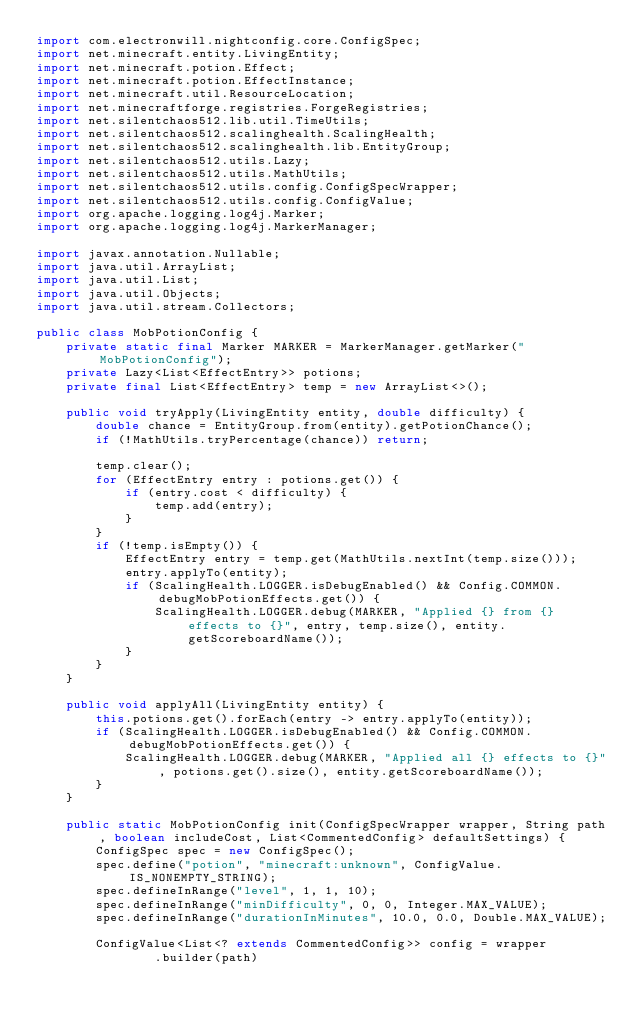Convert code to text. <code><loc_0><loc_0><loc_500><loc_500><_Java_>import com.electronwill.nightconfig.core.ConfigSpec;
import net.minecraft.entity.LivingEntity;
import net.minecraft.potion.Effect;
import net.minecraft.potion.EffectInstance;
import net.minecraft.util.ResourceLocation;
import net.minecraftforge.registries.ForgeRegistries;
import net.silentchaos512.lib.util.TimeUtils;
import net.silentchaos512.scalinghealth.ScalingHealth;
import net.silentchaos512.scalinghealth.lib.EntityGroup;
import net.silentchaos512.utils.Lazy;
import net.silentchaos512.utils.MathUtils;
import net.silentchaos512.utils.config.ConfigSpecWrapper;
import net.silentchaos512.utils.config.ConfigValue;
import org.apache.logging.log4j.Marker;
import org.apache.logging.log4j.MarkerManager;

import javax.annotation.Nullable;
import java.util.ArrayList;
import java.util.List;
import java.util.Objects;
import java.util.stream.Collectors;

public class MobPotionConfig {
    private static final Marker MARKER = MarkerManager.getMarker("MobPotionConfig");
    private Lazy<List<EffectEntry>> potions;
    private final List<EffectEntry> temp = new ArrayList<>();

    public void tryApply(LivingEntity entity, double difficulty) {
        double chance = EntityGroup.from(entity).getPotionChance();
        if (!MathUtils.tryPercentage(chance)) return;

        temp.clear();
        for (EffectEntry entry : potions.get()) {
            if (entry.cost < difficulty) {
                temp.add(entry);
            }
        }
        if (!temp.isEmpty()) {
            EffectEntry entry = temp.get(MathUtils.nextInt(temp.size()));
            entry.applyTo(entity);
            if (ScalingHealth.LOGGER.isDebugEnabled() && Config.COMMON.debugMobPotionEffects.get()) {
                ScalingHealth.LOGGER.debug(MARKER, "Applied {} from {} effects to {}", entry, temp.size(), entity.getScoreboardName());
            }
        }
    }

    public void applyAll(LivingEntity entity) {
        this.potions.get().forEach(entry -> entry.applyTo(entity));
        if (ScalingHealth.LOGGER.isDebugEnabled() && Config.COMMON.debugMobPotionEffects.get()) {
            ScalingHealth.LOGGER.debug(MARKER, "Applied all {} effects to {}", potions.get().size(), entity.getScoreboardName());
        }
    }

    public static MobPotionConfig init(ConfigSpecWrapper wrapper, String path, boolean includeCost, List<CommentedConfig> defaultSettings) {
        ConfigSpec spec = new ConfigSpec();
        spec.define("potion", "minecraft:unknown", ConfigValue.IS_NONEMPTY_STRING);
        spec.defineInRange("level", 1, 1, 10);
        spec.defineInRange("minDifficulty", 0, 0, Integer.MAX_VALUE);
        spec.defineInRange("durationInMinutes", 10.0, 0.0, Double.MAX_VALUE);

        ConfigValue<List<? extends CommentedConfig>> config = wrapper
                .builder(path)</code> 